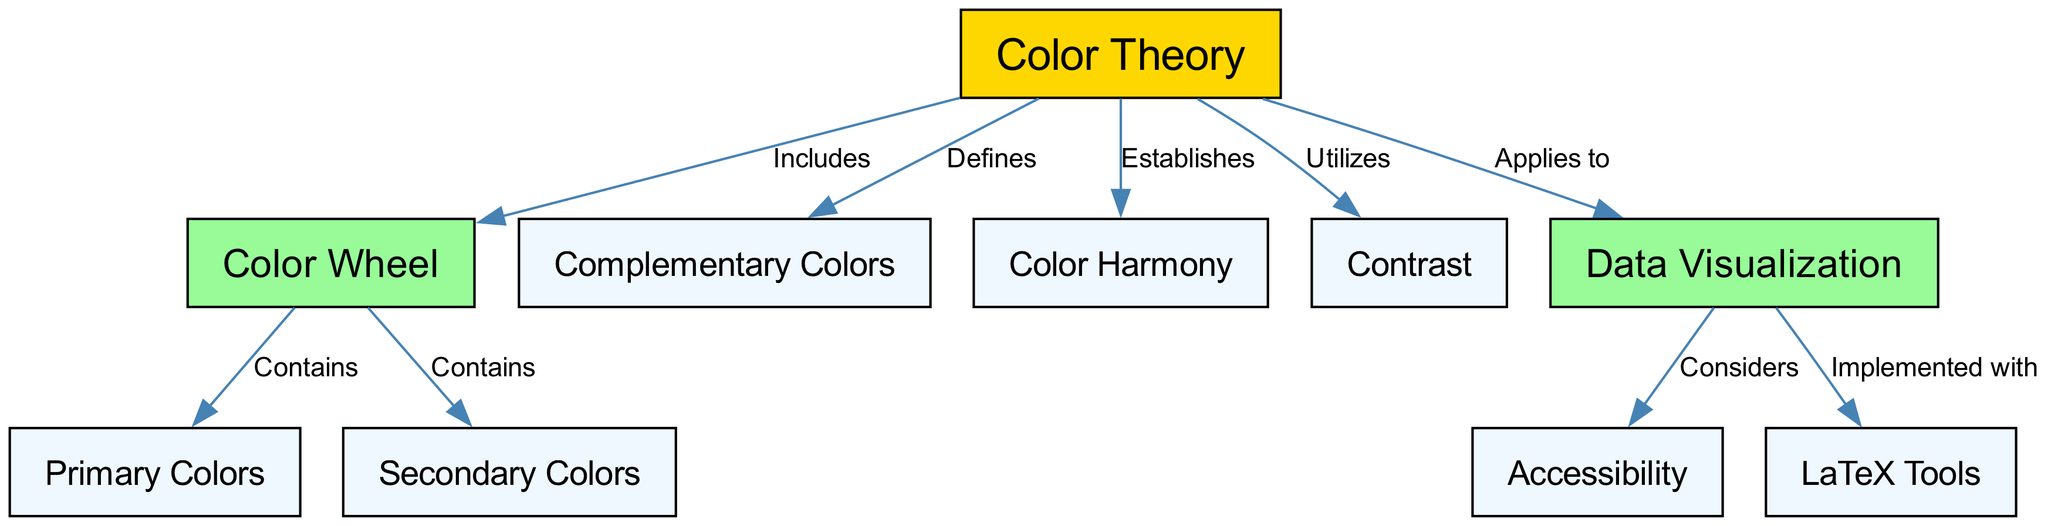What is the main concept represented in the diagram? The main concept is "Color Theory," which is the central node in the diagram from which other concepts branch out.
Answer: Color Theory How many primary colors are identified in the color wheel? The edges from "color_wheel" to "primary_colors" indicate that primary colors are part of the wheel, and it is common knowledge that there are three primary colors in typical color theory.
Answer: Three What concept is defined under color theory related to harmony? "Color Harmony" is directly linked to "Color Theory" by the edge labeled "Establishes." This shows that the theory establishes principles of harmony.
Answer: Color Harmony Which color relationship does the color theory utilize? The edge from "color_theory" to "contrast" indicates that contrast is a relationship utilized by the theory, showcasing its importance in color applications.
Answer: Contrast What does data visualization consider in relation to color theory? The edge from "data_visualization" to "accessibility" shows that accessibility is a key consideration within data visualization when applying color theory principles.
Answer: Accessibility How does color theory apply to scientific visualizations? The edge connecting "color_theory" to "data_visualization" illustrates the application of color theory to create effective scientific visualizations, implying a crucial role.
Answer: Applies to data visualization Which tools are mentioned for implementing color theory in visualizations? The edge from "data_visualization" to "latex_tools" indicates that LaTeX tools are used for implementing color theory effectively in visualizations, especially for scientific illustrations.
Answer: LaTeX Tools What type of colors does the color wheel contain apart from primary colors? The color wheel not only contains primary colors but also has "Secondary Colors," as indicated by the edges branching out from the wheel node.
Answer: Secondary Colors How many edges are there in the diagram? By counting all the lines connecting the nodes, we can see that there are eight edges in total, representing the relationships among the concepts.
Answer: Eight 